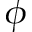Convert formula to latex. <formula><loc_0><loc_0><loc_500><loc_500>\phi</formula> 